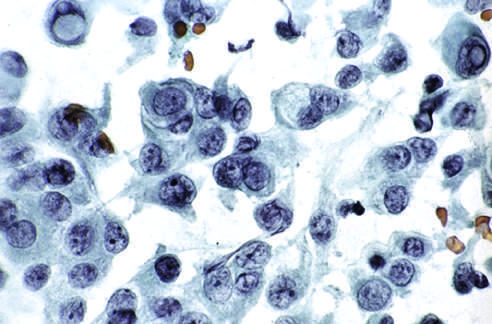how are cells obtained?
Answer the question using a single word or phrase. By fine-needle aspiration of papillary carcinoma 